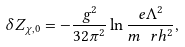Convert formula to latex. <formula><loc_0><loc_0><loc_500><loc_500>\delta Z _ { \chi , 0 } = - \frac { g ^ { 2 } } { 3 2 \pi ^ { 2 } } \ln \frac { e \Lambda ^ { 2 } } { m _ { \ } r h ^ { 2 } } ,</formula> 